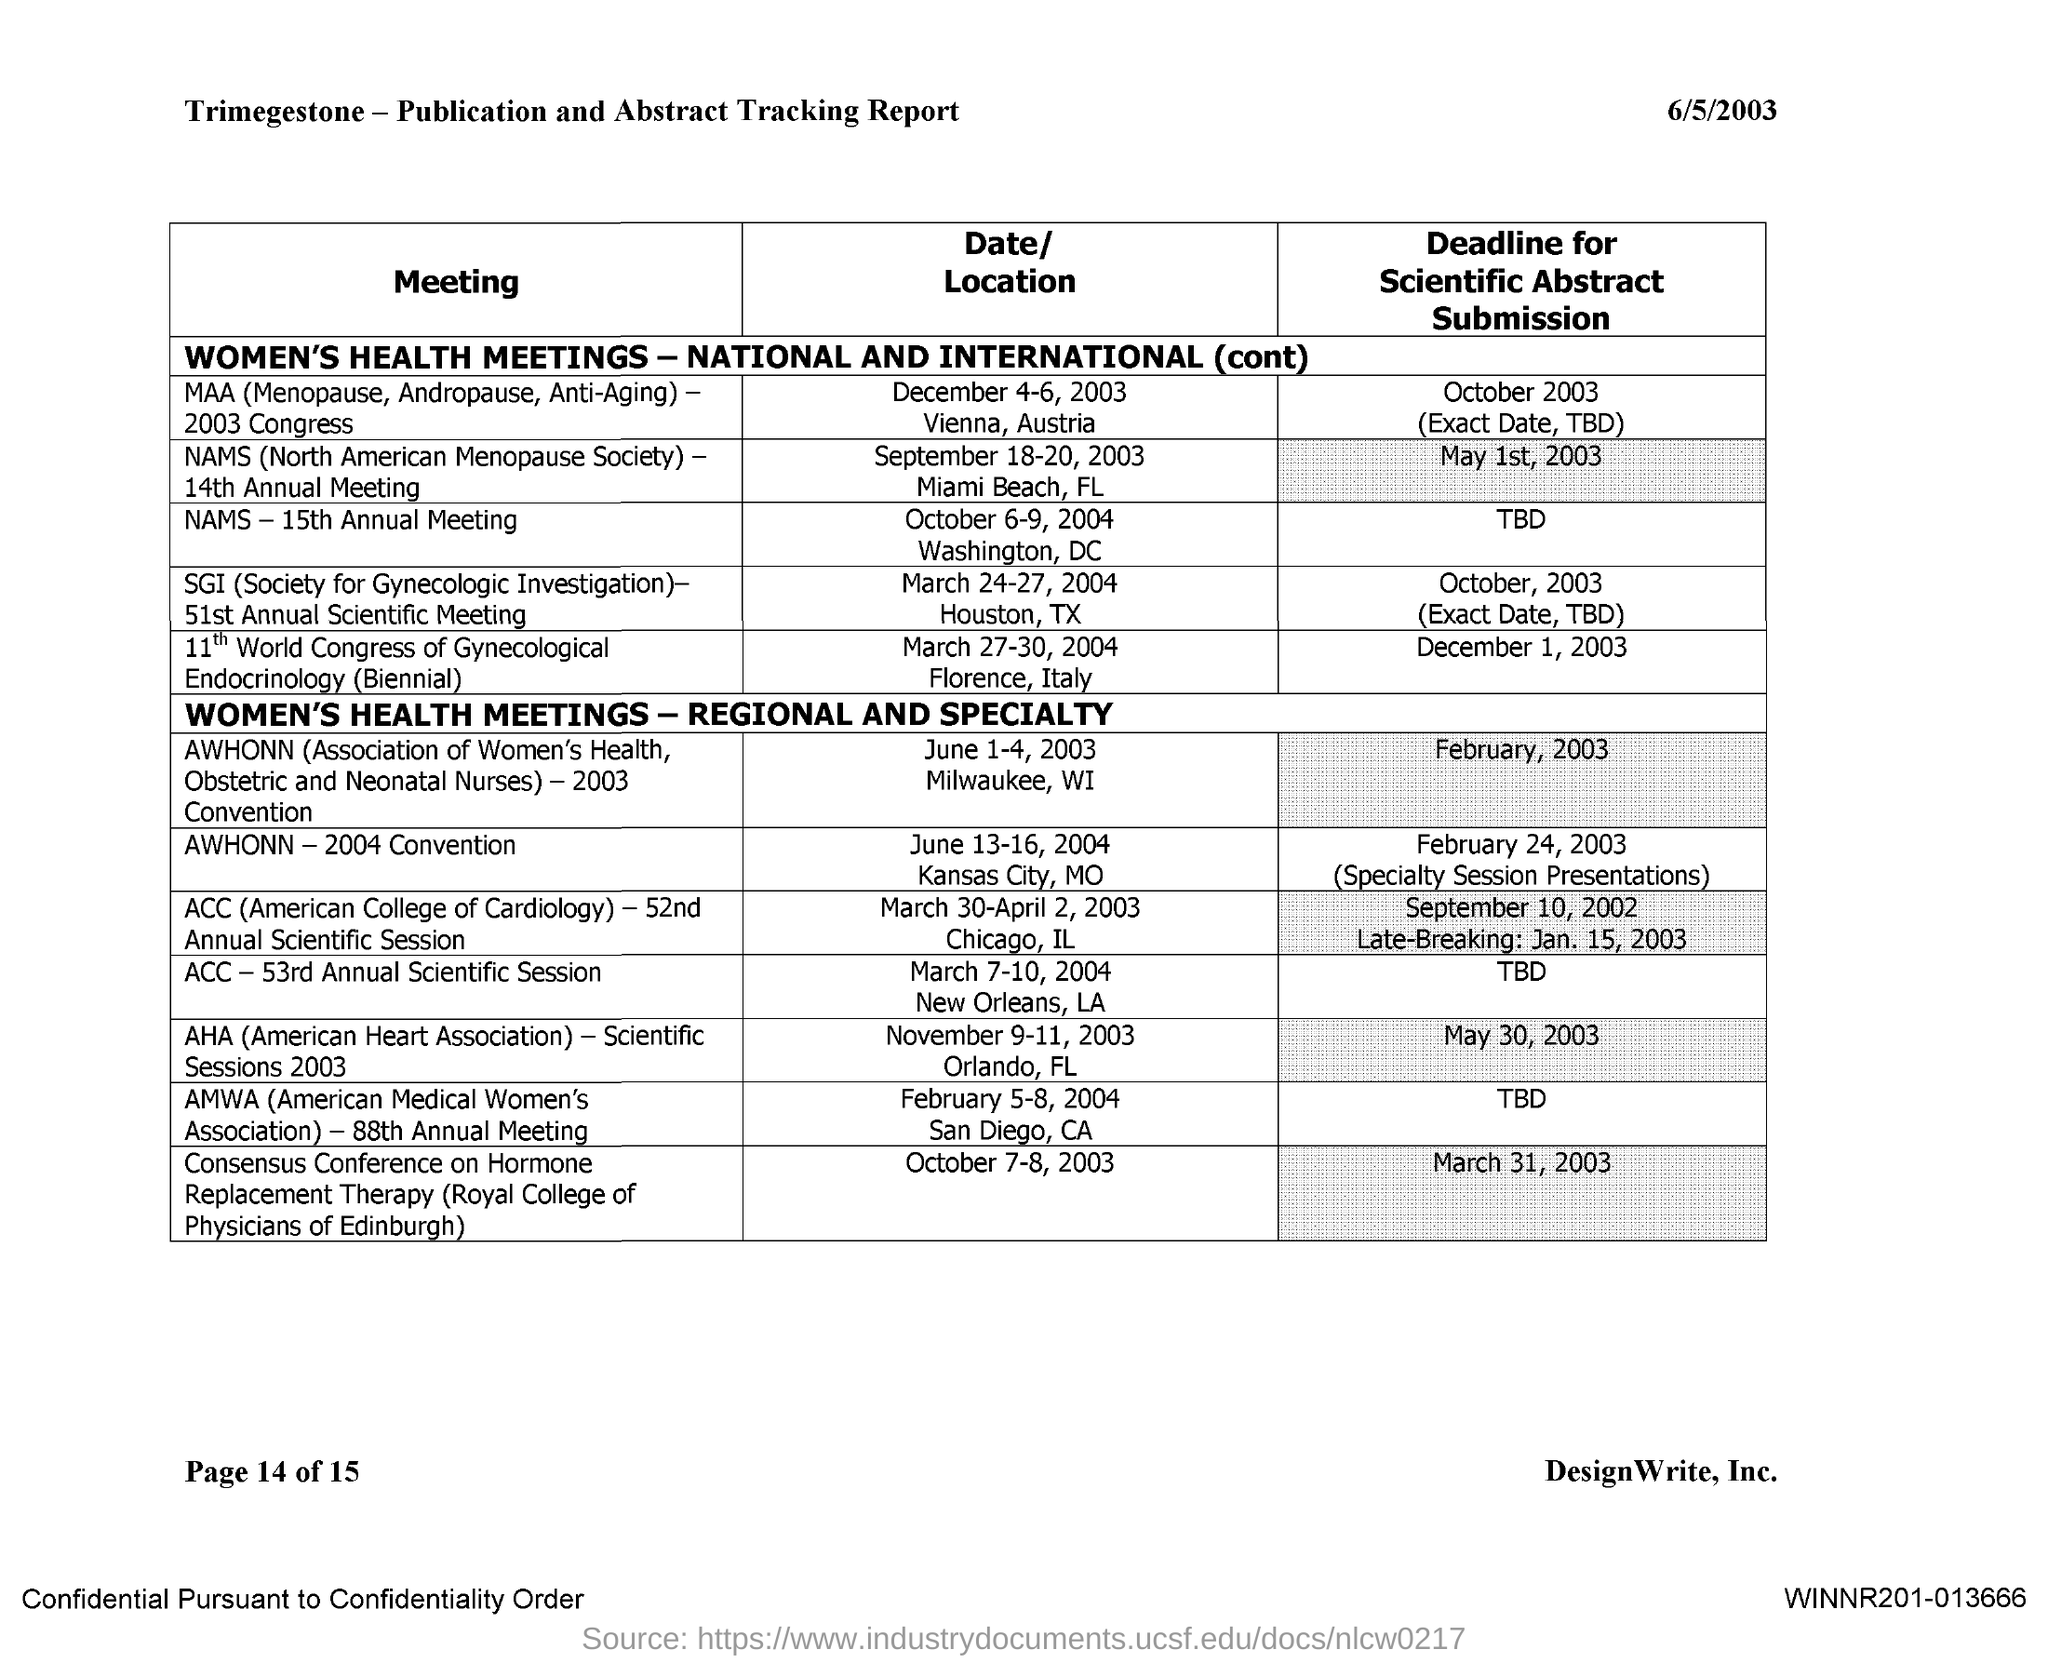Specify some key components in this picture. The deadline for scientific abstract submission for the 15th Annual Meeting of the North American Mycological Society has not yet been determined. The deadline for scientific abstract submission for the AWHONN 2003 Convention is February 2003. The deadline for scientific abstract submission for the ACC - 52nd Annual Scientific Session is September 10, 2002, and the deadline for late-breaking submissions is January 15, 2003. The deadline for scientific abstract submission for the AWHONN 2004 Convention is February 24, 2003. The deadline for scientific abstract submission for the AMWA 88th Annual Meeting has not been determined yet. 